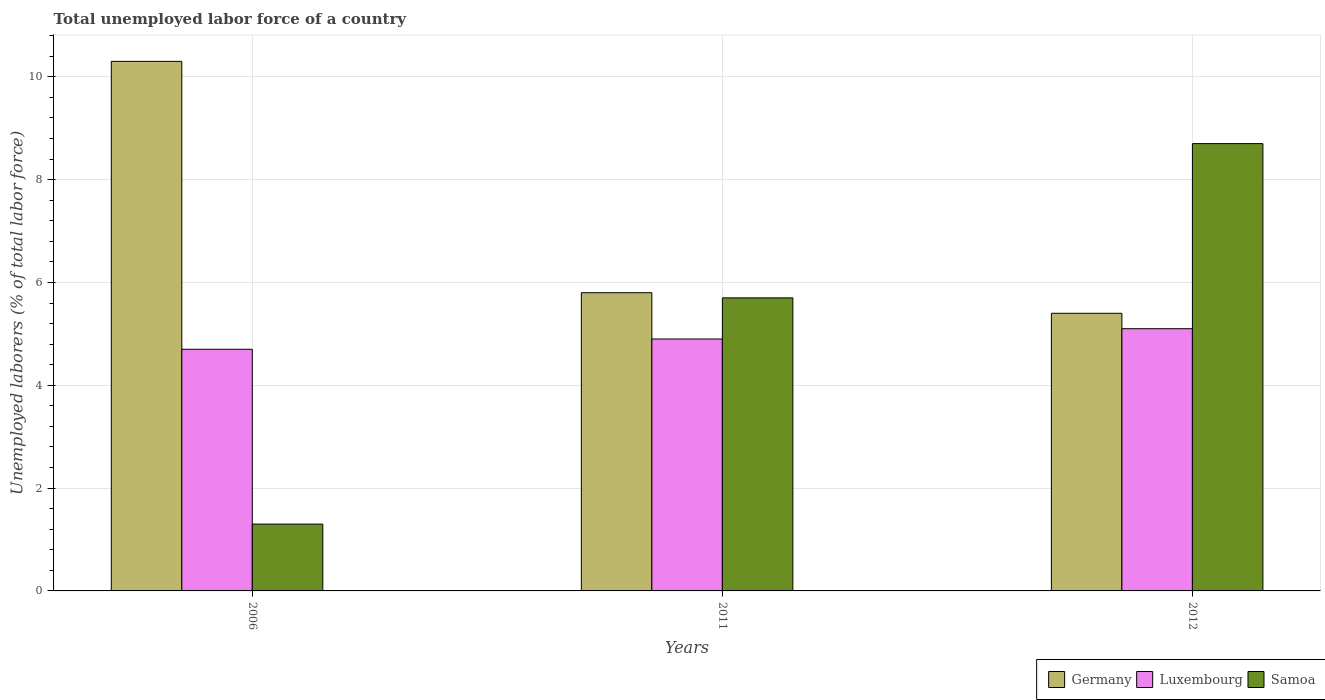How many different coloured bars are there?
Offer a terse response. 3. How many groups of bars are there?
Give a very brief answer. 3. Are the number of bars per tick equal to the number of legend labels?
Keep it short and to the point. Yes. What is the label of the 3rd group of bars from the left?
Give a very brief answer. 2012. What is the total unemployed labor force in Luxembourg in 2012?
Offer a very short reply. 5.1. Across all years, what is the maximum total unemployed labor force in Samoa?
Offer a very short reply. 8.7. Across all years, what is the minimum total unemployed labor force in Samoa?
Offer a terse response. 1.3. In which year was the total unemployed labor force in Luxembourg minimum?
Give a very brief answer. 2006. What is the total total unemployed labor force in Samoa in the graph?
Offer a very short reply. 15.7. What is the difference between the total unemployed labor force in Samoa in 2006 and that in 2012?
Provide a short and direct response. -7.4. What is the difference between the total unemployed labor force in Samoa in 2011 and the total unemployed labor force in Luxembourg in 2006?
Give a very brief answer. 1. What is the average total unemployed labor force in Samoa per year?
Offer a terse response. 5.23. In the year 2006, what is the difference between the total unemployed labor force in Luxembourg and total unemployed labor force in Samoa?
Provide a short and direct response. 3.4. What is the ratio of the total unemployed labor force in Germany in 2006 to that in 2011?
Your response must be concise. 1.78. What is the difference between the highest and the second highest total unemployed labor force in Samoa?
Your response must be concise. 3. What is the difference between the highest and the lowest total unemployed labor force in Samoa?
Offer a very short reply. 7.4. Is the sum of the total unemployed labor force in Samoa in 2006 and 2011 greater than the maximum total unemployed labor force in Luxembourg across all years?
Keep it short and to the point. Yes. What does the 3rd bar from the left in 2012 represents?
Provide a short and direct response. Samoa. What does the 2nd bar from the right in 2012 represents?
Your answer should be compact. Luxembourg. Is it the case that in every year, the sum of the total unemployed labor force in Luxembourg and total unemployed labor force in Germany is greater than the total unemployed labor force in Samoa?
Your answer should be compact. Yes. How many bars are there?
Make the answer very short. 9. How are the legend labels stacked?
Offer a terse response. Horizontal. What is the title of the graph?
Your response must be concise. Total unemployed labor force of a country. What is the label or title of the X-axis?
Your answer should be compact. Years. What is the label or title of the Y-axis?
Ensure brevity in your answer.  Unemployed laborers (% of total labor force). What is the Unemployed laborers (% of total labor force) in Germany in 2006?
Provide a short and direct response. 10.3. What is the Unemployed laborers (% of total labor force) in Luxembourg in 2006?
Keep it short and to the point. 4.7. What is the Unemployed laborers (% of total labor force) of Samoa in 2006?
Your response must be concise. 1.3. What is the Unemployed laborers (% of total labor force) in Germany in 2011?
Your answer should be very brief. 5.8. What is the Unemployed laborers (% of total labor force) of Luxembourg in 2011?
Keep it short and to the point. 4.9. What is the Unemployed laborers (% of total labor force) in Samoa in 2011?
Offer a very short reply. 5.7. What is the Unemployed laborers (% of total labor force) in Germany in 2012?
Make the answer very short. 5.4. What is the Unemployed laborers (% of total labor force) of Luxembourg in 2012?
Make the answer very short. 5.1. What is the Unemployed laborers (% of total labor force) in Samoa in 2012?
Make the answer very short. 8.7. Across all years, what is the maximum Unemployed laborers (% of total labor force) in Germany?
Your answer should be compact. 10.3. Across all years, what is the maximum Unemployed laborers (% of total labor force) in Luxembourg?
Keep it short and to the point. 5.1. Across all years, what is the maximum Unemployed laborers (% of total labor force) in Samoa?
Your answer should be very brief. 8.7. Across all years, what is the minimum Unemployed laborers (% of total labor force) of Germany?
Keep it short and to the point. 5.4. Across all years, what is the minimum Unemployed laborers (% of total labor force) in Luxembourg?
Ensure brevity in your answer.  4.7. Across all years, what is the minimum Unemployed laborers (% of total labor force) of Samoa?
Offer a terse response. 1.3. What is the difference between the Unemployed laborers (% of total labor force) of Germany in 2006 and that in 2011?
Provide a succinct answer. 4.5. What is the difference between the Unemployed laborers (% of total labor force) of Samoa in 2006 and that in 2012?
Give a very brief answer. -7.4. What is the difference between the Unemployed laborers (% of total labor force) in Germany in 2011 and that in 2012?
Provide a succinct answer. 0.4. What is the difference between the Unemployed laborers (% of total labor force) of Samoa in 2011 and that in 2012?
Your answer should be very brief. -3. What is the average Unemployed laborers (% of total labor force) of Germany per year?
Your answer should be very brief. 7.17. What is the average Unemployed laborers (% of total labor force) of Samoa per year?
Your answer should be very brief. 5.23. In the year 2006, what is the difference between the Unemployed laborers (% of total labor force) in Germany and Unemployed laborers (% of total labor force) in Luxembourg?
Offer a very short reply. 5.6. In the year 2011, what is the difference between the Unemployed laborers (% of total labor force) of Germany and Unemployed laborers (% of total labor force) of Samoa?
Give a very brief answer. 0.1. In the year 2011, what is the difference between the Unemployed laborers (% of total labor force) of Luxembourg and Unemployed laborers (% of total labor force) of Samoa?
Make the answer very short. -0.8. In the year 2012, what is the difference between the Unemployed laborers (% of total labor force) of Germany and Unemployed laborers (% of total labor force) of Samoa?
Make the answer very short. -3.3. What is the ratio of the Unemployed laborers (% of total labor force) in Germany in 2006 to that in 2011?
Make the answer very short. 1.78. What is the ratio of the Unemployed laborers (% of total labor force) of Luxembourg in 2006 to that in 2011?
Provide a short and direct response. 0.96. What is the ratio of the Unemployed laborers (% of total labor force) of Samoa in 2006 to that in 2011?
Your answer should be compact. 0.23. What is the ratio of the Unemployed laborers (% of total labor force) in Germany in 2006 to that in 2012?
Provide a succinct answer. 1.91. What is the ratio of the Unemployed laborers (% of total labor force) in Luxembourg in 2006 to that in 2012?
Provide a succinct answer. 0.92. What is the ratio of the Unemployed laborers (% of total labor force) in Samoa in 2006 to that in 2012?
Your answer should be compact. 0.15. What is the ratio of the Unemployed laborers (% of total labor force) in Germany in 2011 to that in 2012?
Your answer should be very brief. 1.07. What is the ratio of the Unemployed laborers (% of total labor force) in Luxembourg in 2011 to that in 2012?
Your answer should be compact. 0.96. What is the ratio of the Unemployed laborers (% of total labor force) in Samoa in 2011 to that in 2012?
Your answer should be compact. 0.66. What is the difference between the highest and the lowest Unemployed laborers (% of total labor force) of Germany?
Keep it short and to the point. 4.9. What is the difference between the highest and the lowest Unemployed laborers (% of total labor force) in Luxembourg?
Your answer should be very brief. 0.4. 